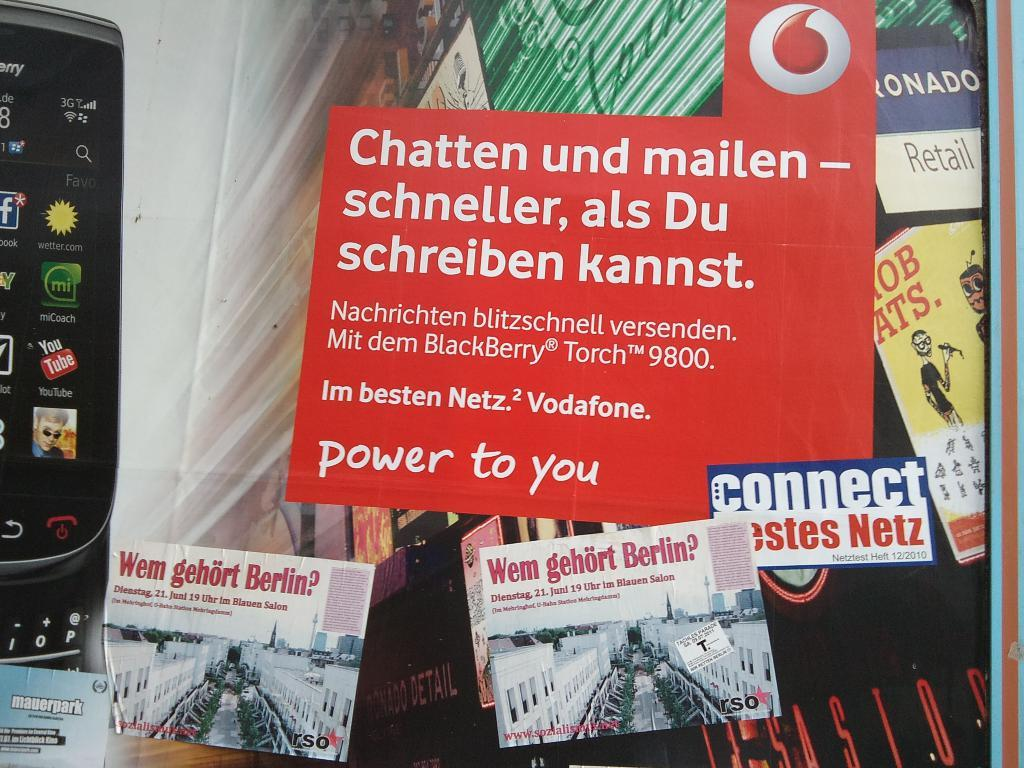<image>
Create a compact narrative representing the image presented. An advertisement for Vodafones sitting above postcards about Berlin. 